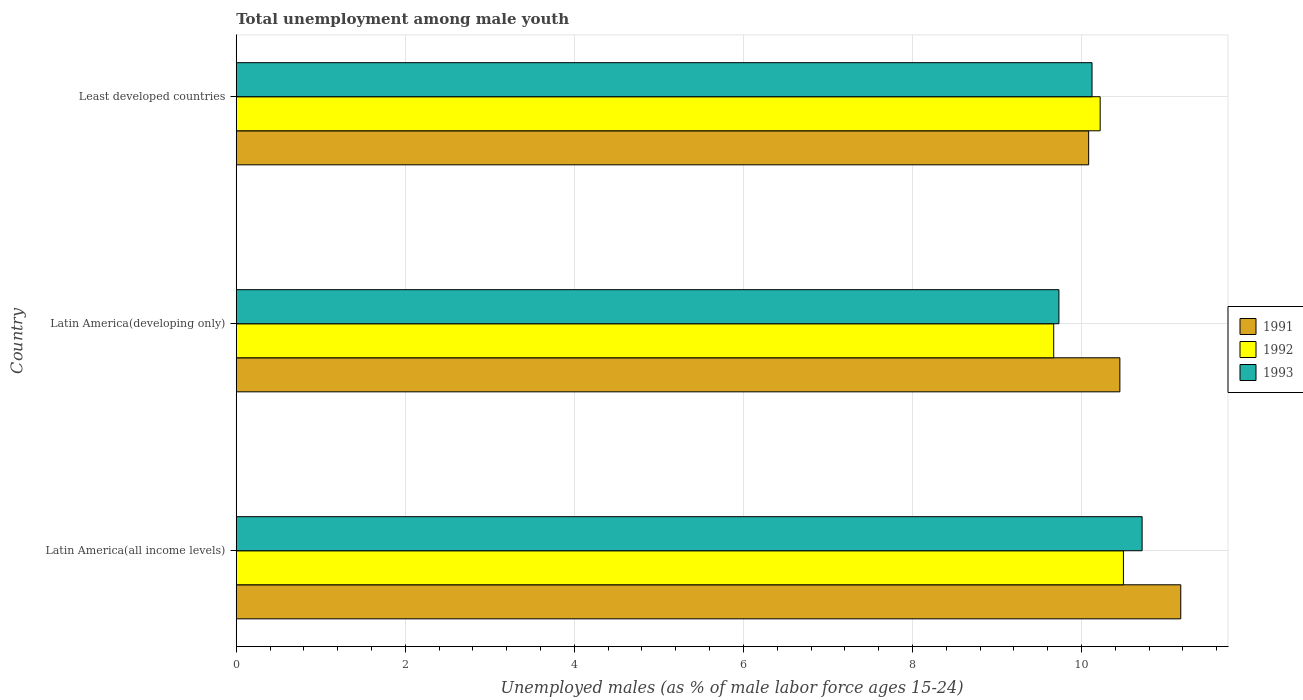Are the number of bars on each tick of the Y-axis equal?
Provide a succinct answer. Yes. How many bars are there on the 3rd tick from the bottom?
Offer a terse response. 3. What is the label of the 2nd group of bars from the top?
Offer a very short reply. Latin America(developing only). In how many cases, is the number of bars for a given country not equal to the number of legend labels?
Make the answer very short. 0. What is the percentage of unemployed males in in 1992 in Least developed countries?
Your answer should be compact. 10.22. Across all countries, what is the maximum percentage of unemployed males in in 1992?
Give a very brief answer. 10.5. Across all countries, what is the minimum percentage of unemployed males in in 1991?
Give a very brief answer. 10.08. In which country was the percentage of unemployed males in in 1993 maximum?
Your answer should be compact. Latin America(all income levels). In which country was the percentage of unemployed males in in 1992 minimum?
Your answer should be compact. Latin America(developing only). What is the total percentage of unemployed males in in 1991 in the graph?
Offer a terse response. 31.71. What is the difference between the percentage of unemployed males in in 1991 in Latin America(developing only) and that in Least developed countries?
Provide a succinct answer. 0.37. What is the difference between the percentage of unemployed males in in 1992 in Latin America(all income levels) and the percentage of unemployed males in in 1993 in Latin America(developing only)?
Offer a very short reply. 0.76. What is the average percentage of unemployed males in in 1992 per country?
Provide a succinct answer. 10.13. What is the difference between the percentage of unemployed males in in 1992 and percentage of unemployed males in in 1993 in Latin America(developing only)?
Keep it short and to the point. -0.06. In how many countries, is the percentage of unemployed males in in 1993 greater than 8.4 %?
Your response must be concise. 3. What is the ratio of the percentage of unemployed males in in 1991 in Latin America(all income levels) to that in Latin America(developing only)?
Your answer should be very brief. 1.07. Is the difference between the percentage of unemployed males in in 1992 in Latin America(all income levels) and Least developed countries greater than the difference between the percentage of unemployed males in in 1993 in Latin America(all income levels) and Least developed countries?
Your answer should be compact. No. What is the difference between the highest and the second highest percentage of unemployed males in in 1992?
Make the answer very short. 0.28. What is the difference between the highest and the lowest percentage of unemployed males in in 1991?
Offer a very short reply. 1.09. What does the 3rd bar from the bottom in Latin America(all income levels) represents?
Provide a short and direct response. 1993. Are all the bars in the graph horizontal?
Your answer should be compact. Yes. How many countries are there in the graph?
Your answer should be very brief. 3. Does the graph contain any zero values?
Keep it short and to the point. No. How many legend labels are there?
Make the answer very short. 3. How are the legend labels stacked?
Your answer should be compact. Vertical. What is the title of the graph?
Your answer should be very brief. Total unemployment among male youth. What is the label or title of the X-axis?
Your answer should be very brief. Unemployed males (as % of male labor force ages 15-24). What is the label or title of the Y-axis?
Make the answer very short. Country. What is the Unemployed males (as % of male labor force ages 15-24) in 1991 in Latin America(all income levels)?
Your response must be concise. 11.17. What is the Unemployed males (as % of male labor force ages 15-24) in 1992 in Latin America(all income levels)?
Offer a terse response. 10.5. What is the Unemployed males (as % of male labor force ages 15-24) of 1993 in Latin America(all income levels)?
Make the answer very short. 10.72. What is the Unemployed males (as % of male labor force ages 15-24) of 1991 in Latin America(developing only)?
Make the answer very short. 10.45. What is the Unemployed males (as % of male labor force ages 15-24) in 1992 in Latin America(developing only)?
Give a very brief answer. 9.67. What is the Unemployed males (as % of male labor force ages 15-24) of 1993 in Latin America(developing only)?
Provide a succinct answer. 9.73. What is the Unemployed males (as % of male labor force ages 15-24) of 1991 in Least developed countries?
Keep it short and to the point. 10.08. What is the Unemployed males (as % of male labor force ages 15-24) in 1992 in Least developed countries?
Offer a very short reply. 10.22. What is the Unemployed males (as % of male labor force ages 15-24) of 1993 in Least developed countries?
Offer a very short reply. 10.12. Across all countries, what is the maximum Unemployed males (as % of male labor force ages 15-24) of 1991?
Ensure brevity in your answer.  11.17. Across all countries, what is the maximum Unemployed males (as % of male labor force ages 15-24) of 1992?
Offer a very short reply. 10.5. Across all countries, what is the maximum Unemployed males (as % of male labor force ages 15-24) of 1993?
Offer a very short reply. 10.72. Across all countries, what is the minimum Unemployed males (as % of male labor force ages 15-24) in 1991?
Ensure brevity in your answer.  10.08. Across all countries, what is the minimum Unemployed males (as % of male labor force ages 15-24) of 1992?
Keep it short and to the point. 9.67. Across all countries, what is the minimum Unemployed males (as % of male labor force ages 15-24) of 1993?
Your response must be concise. 9.73. What is the total Unemployed males (as % of male labor force ages 15-24) of 1991 in the graph?
Offer a terse response. 31.71. What is the total Unemployed males (as % of male labor force ages 15-24) of 1992 in the graph?
Give a very brief answer. 30.39. What is the total Unemployed males (as % of male labor force ages 15-24) of 1993 in the graph?
Offer a terse response. 30.58. What is the difference between the Unemployed males (as % of male labor force ages 15-24) in 1991 in Latin America(all income levels) and that in Latin America(developing only)?
Provide a succinct answer. 0.72. What is the difference between the Unemployed males (as % of male labor force ages 15-24) of 1992 in Latin America(all income levels) and that in Latin America(developing only)?
Ensure brevity in your answer.  0.82. What is the difference between the Unemployed males (as % of male labor force ages 15-24) of 1993 in Latin America(all income levels) and that in Latin America(developing only)?
Provide a short and direct response. 0.98. What is the difference between the Unemployed males (as % of male labor force ages 15-24) of 1991 in Latin America(all income levels) and that in Least developed countries?
Ensure brevity in your answer.  1.09. What is the difference between the Unemployed males (as % of male labor force ages 15-24) of 1992 in Latin America(all income levels) and that in Least developed countries?
Your answer should be very brief. 0.28. What is the difference between the Unemployed males (as % of male labor force ages 15-24) of 1993 in Latin America(all income levels) and that in Least developed countries?
Ensure brevity in your answer.  0.59. What is the difference between the Unemployed males (as % of male labor force ages 15-24) of 1991 in Latin America(developing only) and that in Least developed countries?
Offer a very short reply. 0.37. What is the difference between the Unemployed males (as % of male labor force ages 15-24) in 1992 in Latin America(developing only) and that in Least developed countries?
Keep it short and to the point. -0.55. What is the difference between the Unemployed males (as % of male labor force ages 15-24) of 1993 in Latin America(developing only) and that in Least developed countries?
Your answer should be compact. -0.39. What is the difference between the Unemployed males (as % of male labor force ages 15-24) of 1991 in Latin America(all income levels) and the Unemployed males (as % of male labor force ages 15-24) of 1992 in Latin America(developing only)?
Make the answer very short. 1.5. What is the difference between the Unemployed males (as % of male labor force ages 15-24) of 1991 in Latin America(all income levels) and the Unemployed males (as % of male labor force ages 15-24) of 1993 in Latin America(developing only)?
Your response must be concise. 1.44. What is the difference between the Unemployed males (as % of male labor force ages 15-24) in 1992 in Latin America(all income levels) and the Unemployed males (as % of male labor force ages 15-24) in 1993 in Latin America(developing only)?
Your answer should be very brief. 0.76. What is the difference between the Unemployed males (as % of male labor force ages 15-24) of 1991 in Latin America(all income levels) and the Unemployed males (as % of male labor force ages 15-24) of 1992 in Least developed countries?
Offer a terse response. 0.95. What is the difference between the Unemployed males (as % of male labor force ages 15-24) in 1991 in Latin America(all income levels) and the Unemployed males (as % of male labor force ages 15-24) in 1993 in Least developed countries?
Provide a short and direct response. 1.05. What is the difference between the Unemployed males (as % of male labor force ages 15-24) in 1992 in Latin America(all income levels) and the Unemployed males (as % of male labor force ages 15-24) in 1993 in Least developed countries?
Keep it short and to the point. 0.37. What is the difference between the Unemployed males (as % of male labor force ages 15-24) in 1991 in Latin America(developing only) and the Unemployed males (as % of male labor force ages 15-24) in 1992 in Least developed countries?
Make the answer very short. 0.23. What is the difference between the Unemployed males (as % of male labor force ages 15-24) in 1991 in Latin America(developing only) and the Unemployed males (as % of male labor force ages 15-24) in 1993 in Least developed countries?
Provide a succinct answer. 0.33. What is the difference between the Unemployed males (as % of male labor force ages 15-24) in 1992 in Latin America(developing only) and the Unemployed males (as % of male labor force ages 15-24) in 1993 in Least developed countries?
Your response must be concise. -0.45. What is the average Unemployed males (as % of male labor force ages 15-24) in 1991 per country?
Your answer should be very brief. 10.57. What is the average Unemployed males (as % of male labor force ages 15-24) in 1992 per country?
Ensure brevity in your answer.  10.13. What is the average Unemployed males (as % of male labor force ages 15-24) of 1993 per country?
Give a very brief answer. 10.19. What is the difference between the Unemployed males (as % of male labor force ages 15-24) of 1991 and Unemployed males (as % of male labor force ages 15-24) of 1992 in Latin America(all income levels)?
Ensure brevity in your answer.  0.68. What is the difference between the Unemployed males (as % of male labor force ages 15-24) in 1991 and Unemployed males (as % of male labor force ages 15-24) in 1993 in Latin America(all income levels)?
Make the answer very short. 0.46. What is the difference between the Unemployed males (as % of male labor force ages 15-24) in 1992 and Unemployed males (as % of male labor force ages 15-24) in 1993 in Latin America(all income levels)?
Keep it short and to the point. -0.22. What is the difference between the Unemployed males (as % of male labor force ages 15-24) of 1991 and Unemployed males (as % of male labor force ages 15-24) of 1992 in Latin America(developing only)?
Ensure brevity in your answer.  0.78. What is the difference between the Unemployed males (as % of male labor force ages 15-24) in 1991 and Unemployed males (as % of male labor force ages 15-24) in 1993 in Latin America(developing only)?
Keep it short and to the point. 0.72. What is the difference between the Unemployed males (as % of male labor force ages 15-24) in 1992 and Unemployed males (as % of male labor force ages 15-24) in 1993 in Latin America(developing only)?
Ensure brevity in your answer.  -0.06. What is the difference between the Unemployed males (as % of male labor force ages 15-24) in 1991 and Unemployed males (as % of male labor force ages 15-24) in 1992 in Least developed countries?
Keep it short and to the point. -0.14. What is the difference between the Unemployed males (as % of male labor force ages 15-24) in 1991 and Unemployed males (as % of male labor force ages 15-24) in 1993 in Least developed countries?
Make the answer very short. -0.04. What is the difference between the Unemployed males (as % of male labor force ages 15-24) of 1992 and Unemployed males (as % of male labor force ages 15-24) of 1993 in Least developed countries?
Offer a very short reply. 0.1. What is the ratio of the Unemployed males (as % of male labor force ages 15-24) of 1991 in Latin America(all income levels) to that in Latin America(developing only)?
Give a very brief answer. 1.07. What is the ratio of the Unemployed males (as % of male labor force ages 15-24) in 1992 in Latin America(all income levels) to that in Latin America(developing only)?
Make the answer very short. 1.09. What is the ratio of the Unemployed males (as % of male labor force ages 15-24) of 1993 in Latin America(all income levels) to that in Latin America(developing only)?
Ensure brevity in your answer.  1.1. What is the ratio of the Unemployed males (as % of male labor force ages 15-24) in 1991 in Latin America(all income levels) to that in Least developed countries?
Offer a very short reply. 1.11. What is the ratio of the Unemployed males (as % of male labor force ages 15-24) of 1992 in Latin America(all income levels) to that in Least developed countries?
Your answer should be compact. 1.03. What is the ratio of the Unemployed males (as % of male labor force ages 15-24) of 1993 in Latin America(all income levels) to that in Least developed countries?
Your response must be concise. 1.06. What is the ratio of the Unemployed males (as % of male labor force ages 15-24) of 1991 in Latin America(developing only) to that in Least developed countries?
Offer a terse response. 1.04. What is the ratio of the Unemployed males (as % of male labor force ages 15-24) in 1992 in Latin America(developing only) to that in Least developed countries?
Offer a terse response. 0.95. What is the ratio of the Unemployed males (as % of male labor force ages 15-24) of 1993 in Latin America(developing only) to that in Least developed countries?
Keep it short and to the point. 0.96. What is the difference between the highest and the second highest Unemployed males (as % of male labor force ages 15-24) in 1991?
Provide a succinct answer. 0.72. What is the difference between the highest and the second highest Unemployed males (as % of male labor force ages 15-24) of 1992?
Provide a short and direct response. 0.28. What is the difference between the highest and the second highest Unemployed males (as % of male labor force ages 15-24) of 1993?
Make the answer very short. 0.59. What is the difference between the highest and the lowest Unemployed males (as % of male labor force ages 15-24) in 1991?
Offer a very short reply. 1.09. What is the difference between the highest and the lowest Unemployed males (as % of male labor force ages 15-24) of 1992?
Provide a short and direct response. 0.82. What is the difference between the highest and the lowest Unemployed males (as % of male labor force ages 15-24) of 1993?
Your response must be concise. 0.98. 